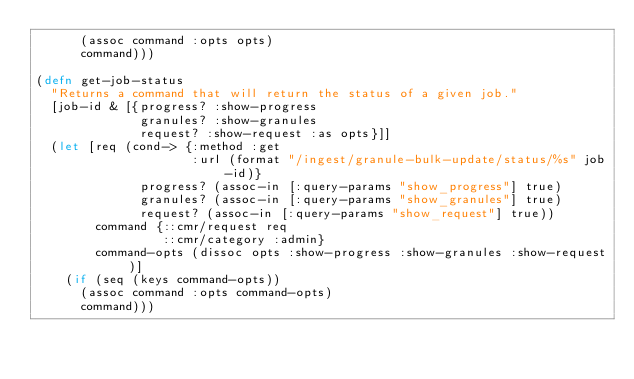<code> <loc_0><loc_0><loc_500><loc_500><_Clojure_>      (assoc command :opts opts)
      command)))

(defn get-job-status
  "Returns a command that will return the status of a given job."
  [job-id & [{progress? :show-progress
              granules? :show-granules
              request? :show-request :as opts}]]
  (let [req (cond-> {:method :get
                     :url (format "/ingest/granule-bulk-update/status/%s" job-id)}
              progress? (assoc-in [:query-params "show_progress"] true)
              granules? (assoc-in [:query-params "show_granules"] true)
              request? (assoc-in [:query-params "show_request"] true))
        command {::cmr/request req
                 ::cmr/category :admin}
        command-opts (dissoc opts :show-progress :show-granules :show-request)]
    (if (seq (keys command-opts))
      (assoc command :opts command-opts)
      command)))
</code> 